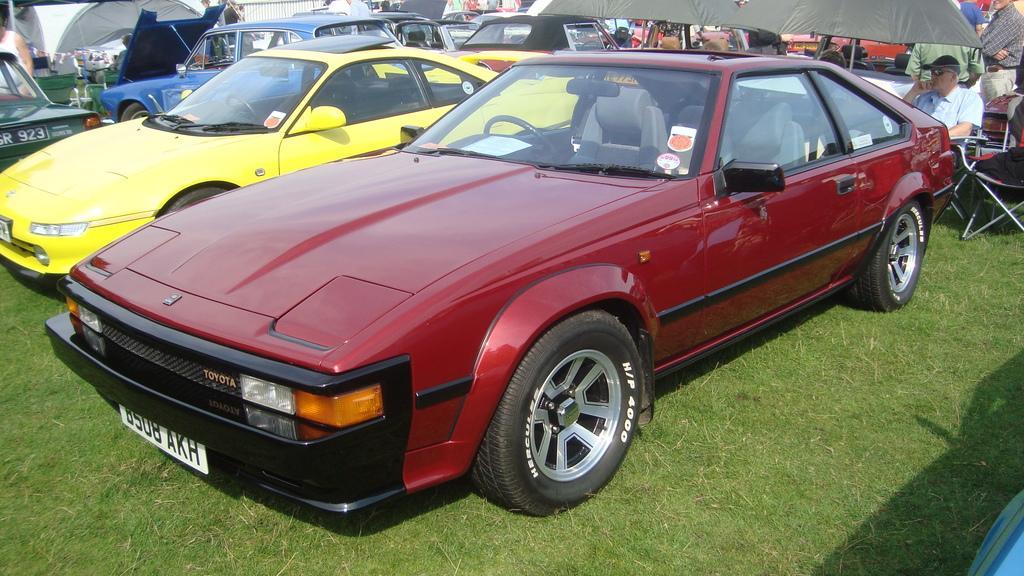In one or two sentences, can you explain what this image depicts? In this image there are so many vehicles parked on the surface of the grass, there are a few canopy's, beneath that there are a few people sitting on the chairs and few are standing. 